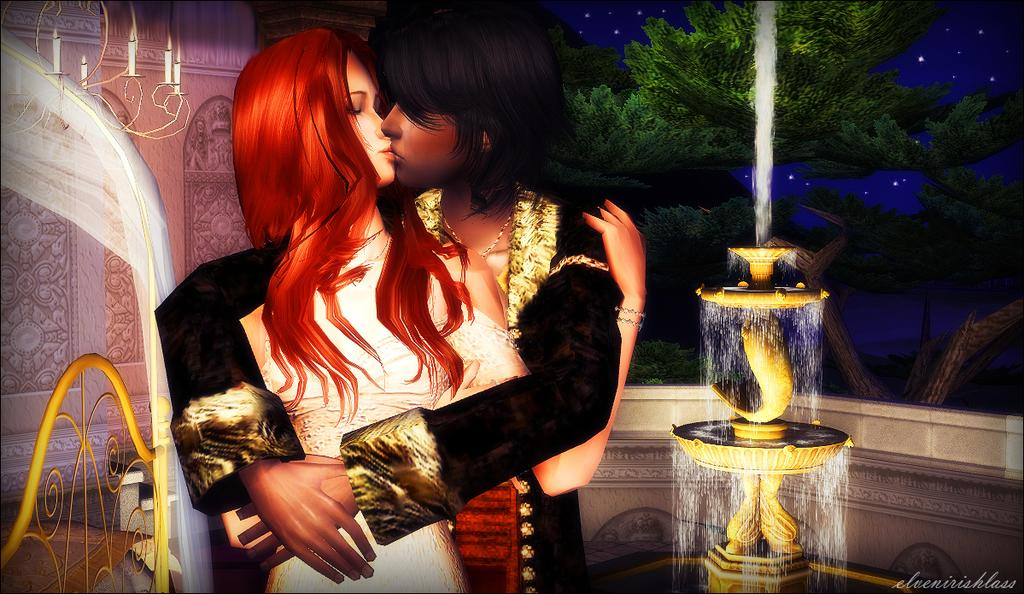What are the main subjects in the image? There is a depiction of a man and a woman in the image. What can be seen in the background of the image? There are trees in the background of the image. What is a notable feature in the image? There is a fountain in the image. What type of cap is the man wearing in the image? There is no cap visible on the man in the image. What type of station is depicted in the image? There is no station depicted in the image; it features a man, a woman, trees, and a fountain. 